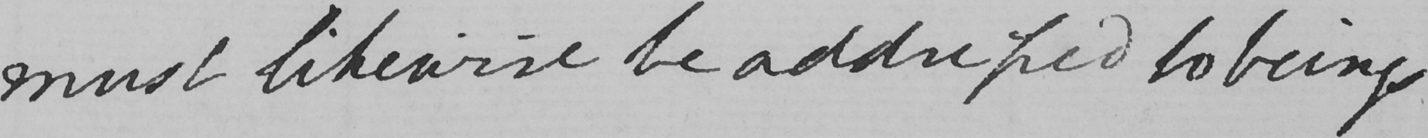Please provide the text content of this handwritten line. must likewise be addressed to beings 